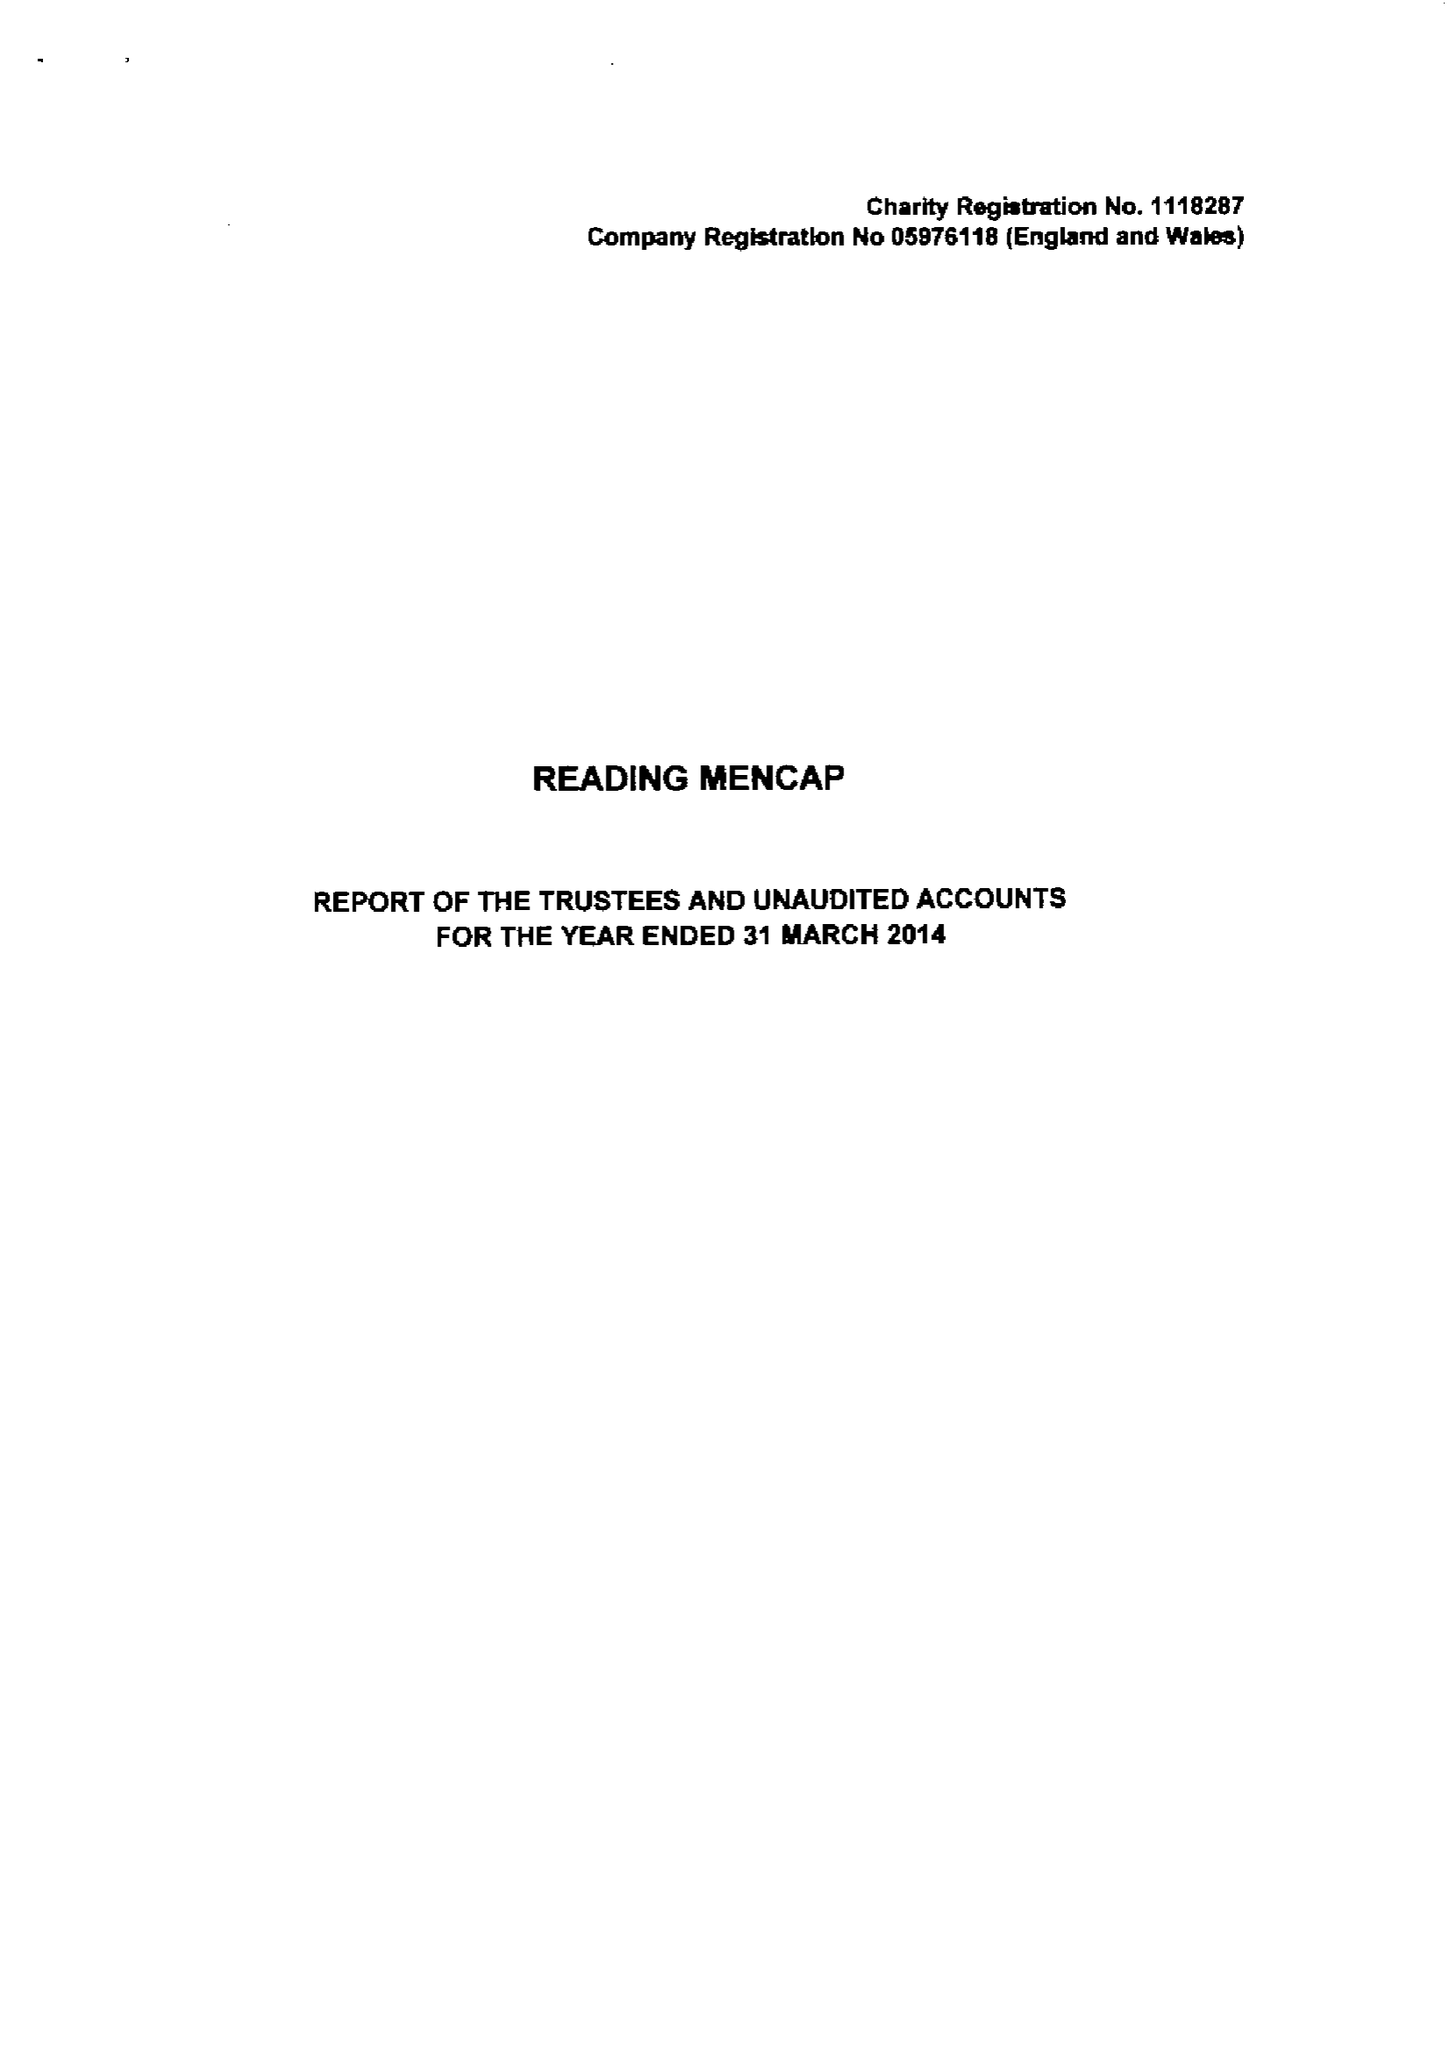What is the value for the charity_name?
Answer the question using a single word or phrase. Reading Mencap 